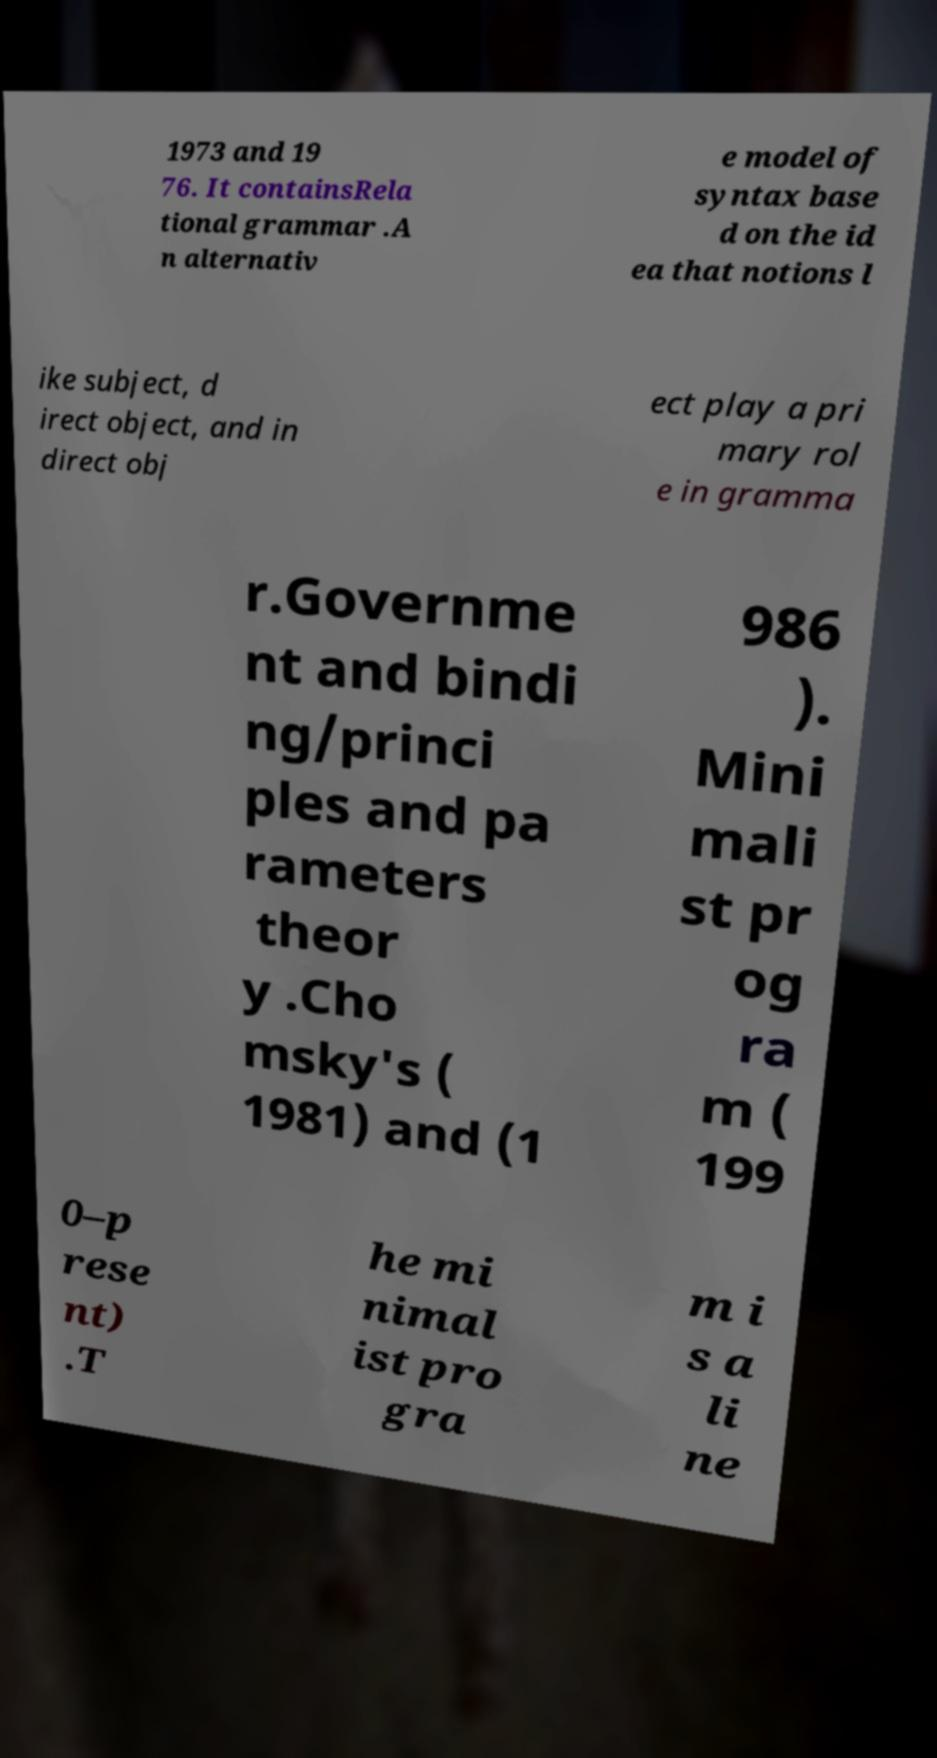For documentation purposes, I need the text within this image transcribed. Could you provide that? 1973 and 19 76. It containsRela tional grammar .A n alternativ e model of syntax base d on the id ea that notions l ike subject, d irect object, and in direct obj ect play a pri mary rol e in gramma r.Governme nt and bindi ng/princi ples and pa rameters theor y .Cho msky's ( 1981) and (1 986 ). Mini mali st pr og ra m ( 199 0–p rese nt) .T he mi nimal ist pro gra m i s a li ne 